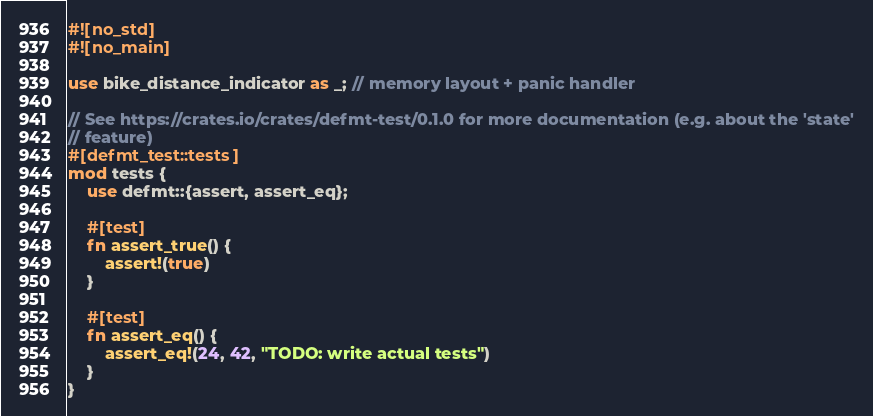<code> <loc_0><loc_0><loc_500><loc_500><_Rust_>#![no_std]
#![no_main]

use bike_distance_indicator as _; // memory layout + panic handler

// See https://crates.io/crates/defmt-test/0.1.0 for more documentation (e.g. about the 'state'
// feature)
#[defmt_test::tests]
mod tests {
    use defmt::{assert, assert_eq};

    #[test]
    fn assert_true() {
        assert!(true)
    }

    #[test]
    fn assert_eq() {
        assert_eq!(24, 42, "TODO: write actual tests")
    }
}
</code> 